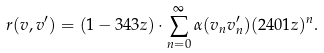<formula> <loc_0><loc_0><loc_500><loc_500>r ( v , v ^ { \prime } ) = ( 1 - 3 4 3 { z } ) \cdot \sum _ { n = 0 } ^ { \infty } \alpha ( v _ { n } v ^ { \prime } _ { n } ) ( 2 4 0 1 { z } ) ^ { n } .</formula> 